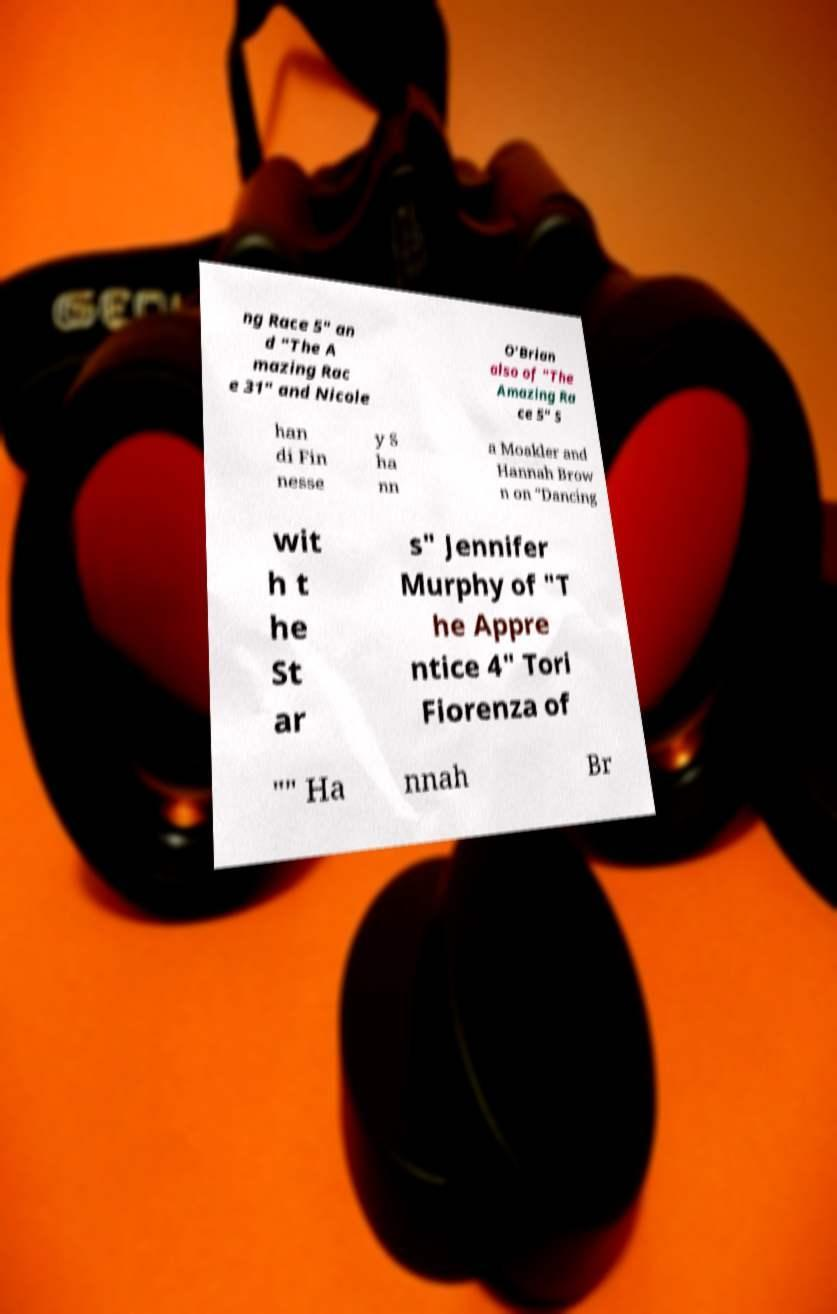Can you read and provide the text displayed in the image?This photo seems to have some interesting text. Can you extract and type it out for me? ng Race 5" an d "The A mazing Rac e 31" and Nicole O'Brian also of "The Amazing Ra ce 5" S han di Fin nesse y S ha nn a Moakler and Hannah Brow n on "Dancing wit h t he St ar s" Jennifer Murphy of "T he Appre ntice 4" Tori Fiorenza of "" Ha nnah Br 